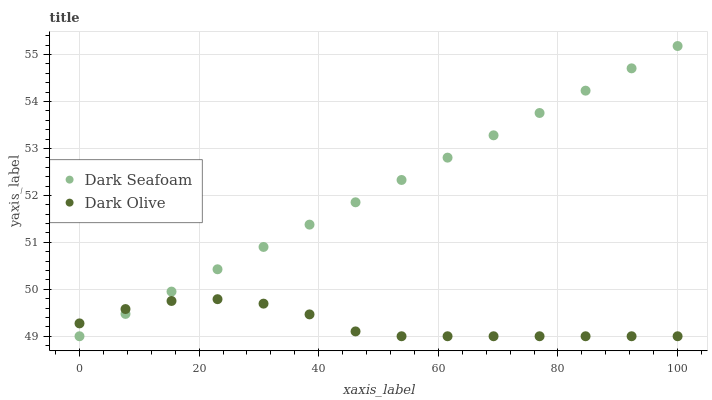Does Dark Olive have the minimum area under the curve?
Answer yes or no. Yes. Does Dark Seafoam have the maximum area under the curve?
Answer yes or no. Yes. Does Dark Olive have the maximum area under the curve?
Answer yes or no. No. Is Dark Seafoam the smoothest?
Answer yes or no. Yes. Is Dark Olive the roughest?
Answer yes or no. Yes. Is Dark Olive the smoothest?
Answer yes or no. No. Does Dark Seafoam have the lowest value?
Answer yes or no. Yes. Does Dark Seafoam have the highest value?
Answer yes or no. Yes. Does Dark Olive have the highest value?
Answer yes or no. No. Does Dark Seafoam intersect Dark Olive?
Answer yes or no. Yes. Is Dark Seafoam less than Dark Olive?
Answer yes or no. No. Is Dark Seafoam greater than Dark Olive?
Answer yes or no. No. 